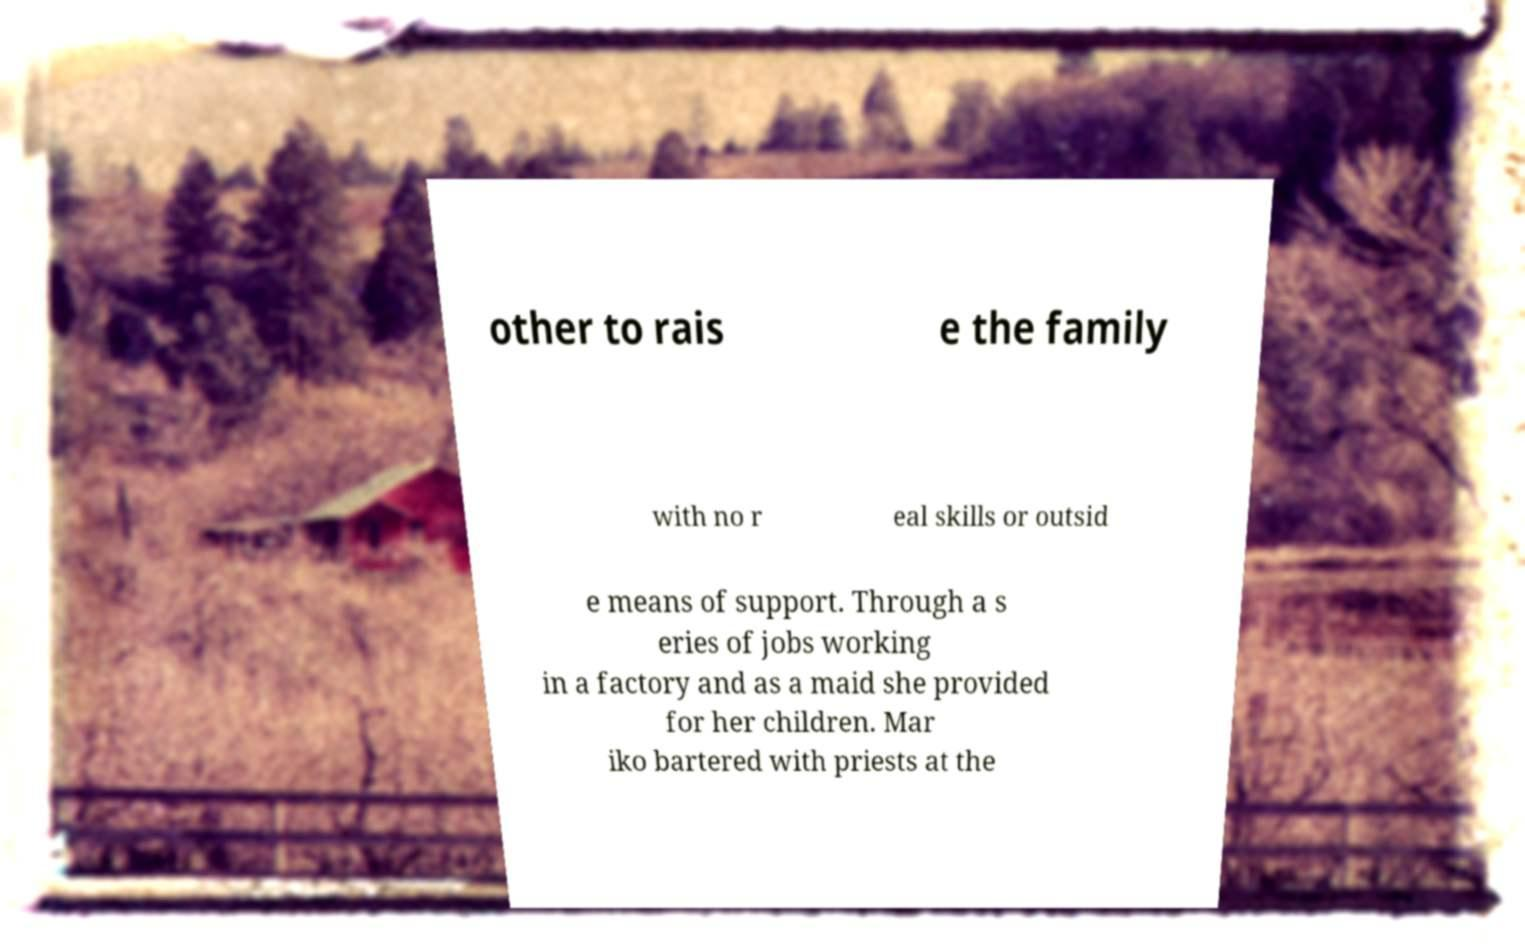For documentation purposes, I need the text within this image transcribed. Could you provide that? other to rais e the family with no r eal skills or outsid e means of support. Through a s eries of jobs working in a factory and as a maid she provided for her children. Mar iko bartered with priests at the 